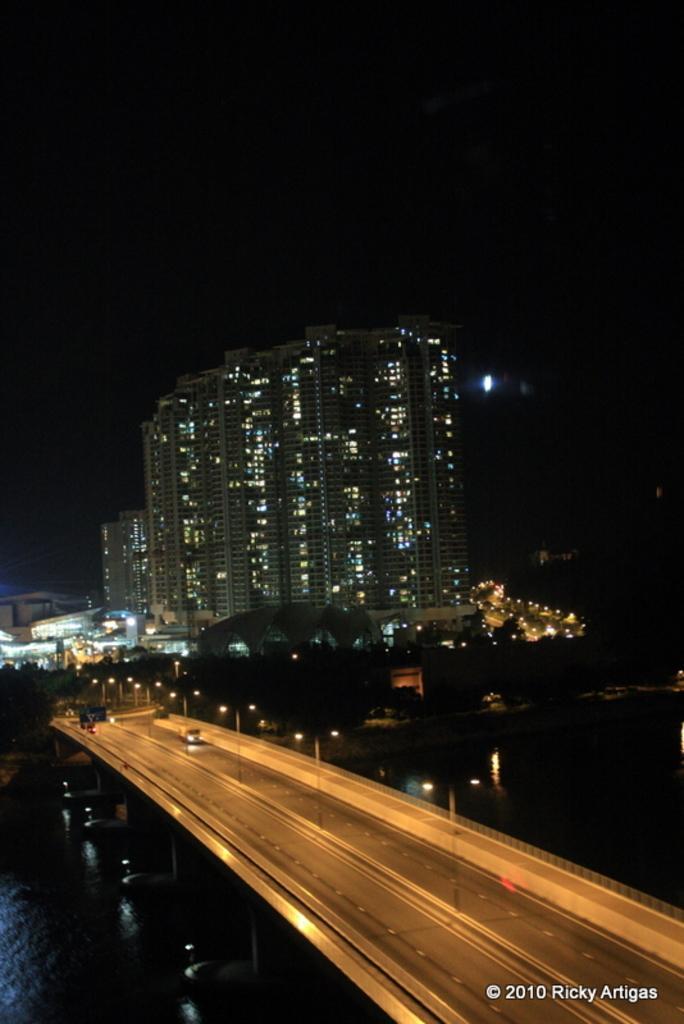In one or two sentences, can you explain what this image depicts? In this image there is a bridge having street lights. Below the bridge there is water. Few vehicles are on the bridge. Background there are trees and buildings. Top of the image there is sky. 